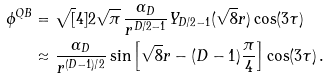Convert formula to latex. <formula><loc_0><loc_0><loc_500><loc_500>\phi ^ { Q B } & = \sqrt { [ } 4 ] { 2 } \sqrt { \pi } \, \frac { \alpha _ { D } } { r ^ { D / 2 - 1 } } Y _ { D / 2 - 1 } ( \sqrt { 8 } r ) \cos ( 3 \tau ) \\ & \approx \frac { \alpha _ { D } } { r ^ { ( D - 1 ) / 2 } } \sin \left [ \sqrt { 8 } r - ( D - 1 ) \frac { \pi } { 4 } \right ] \cos ( 3 \tau ) \, .</formula> 